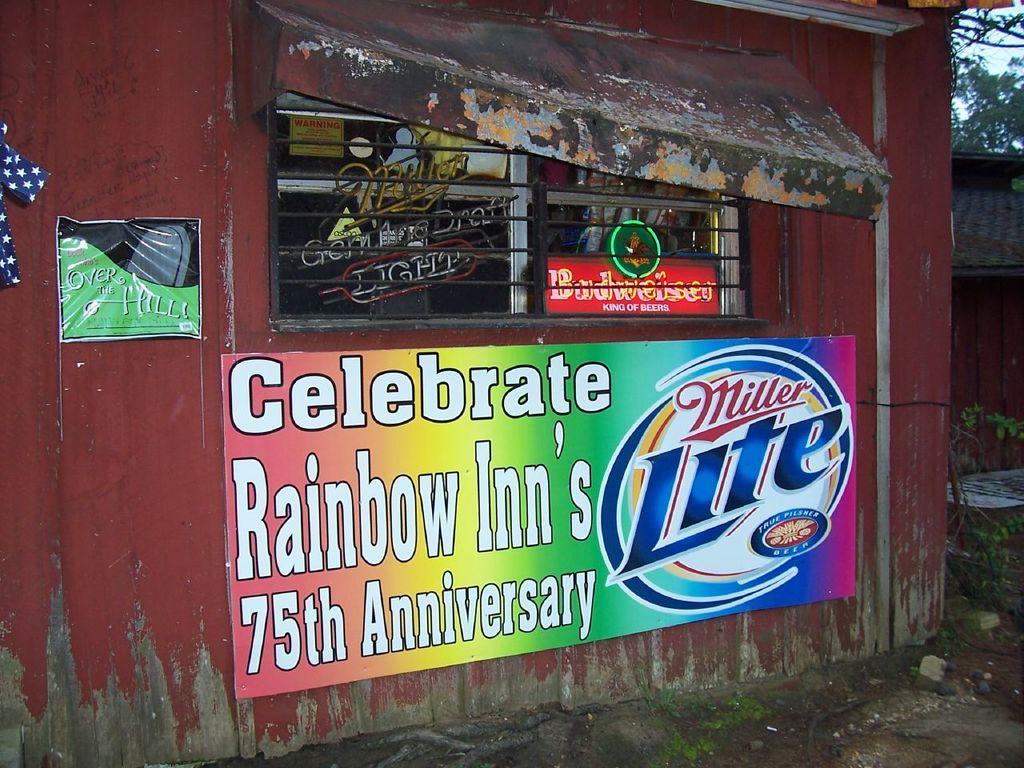In one or two sentences, can you explain what this image depicts? On the left side, there are two posters attached to the brown color wall of a building, which is having a window. Through this window, we can see there is a poster and there are other other objects. On the right side, there are plants, trees and sky. 